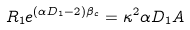Convert formula to latex. <formula><loc_0><loc_0><loc_500><loc_500>R _ { 1 } e ^ { ( \alpha D _ { 1 } - 2 ) \beta _ { c } } = \kappa ^ { 2 } \alpha D _ { 1 } A</formula> 